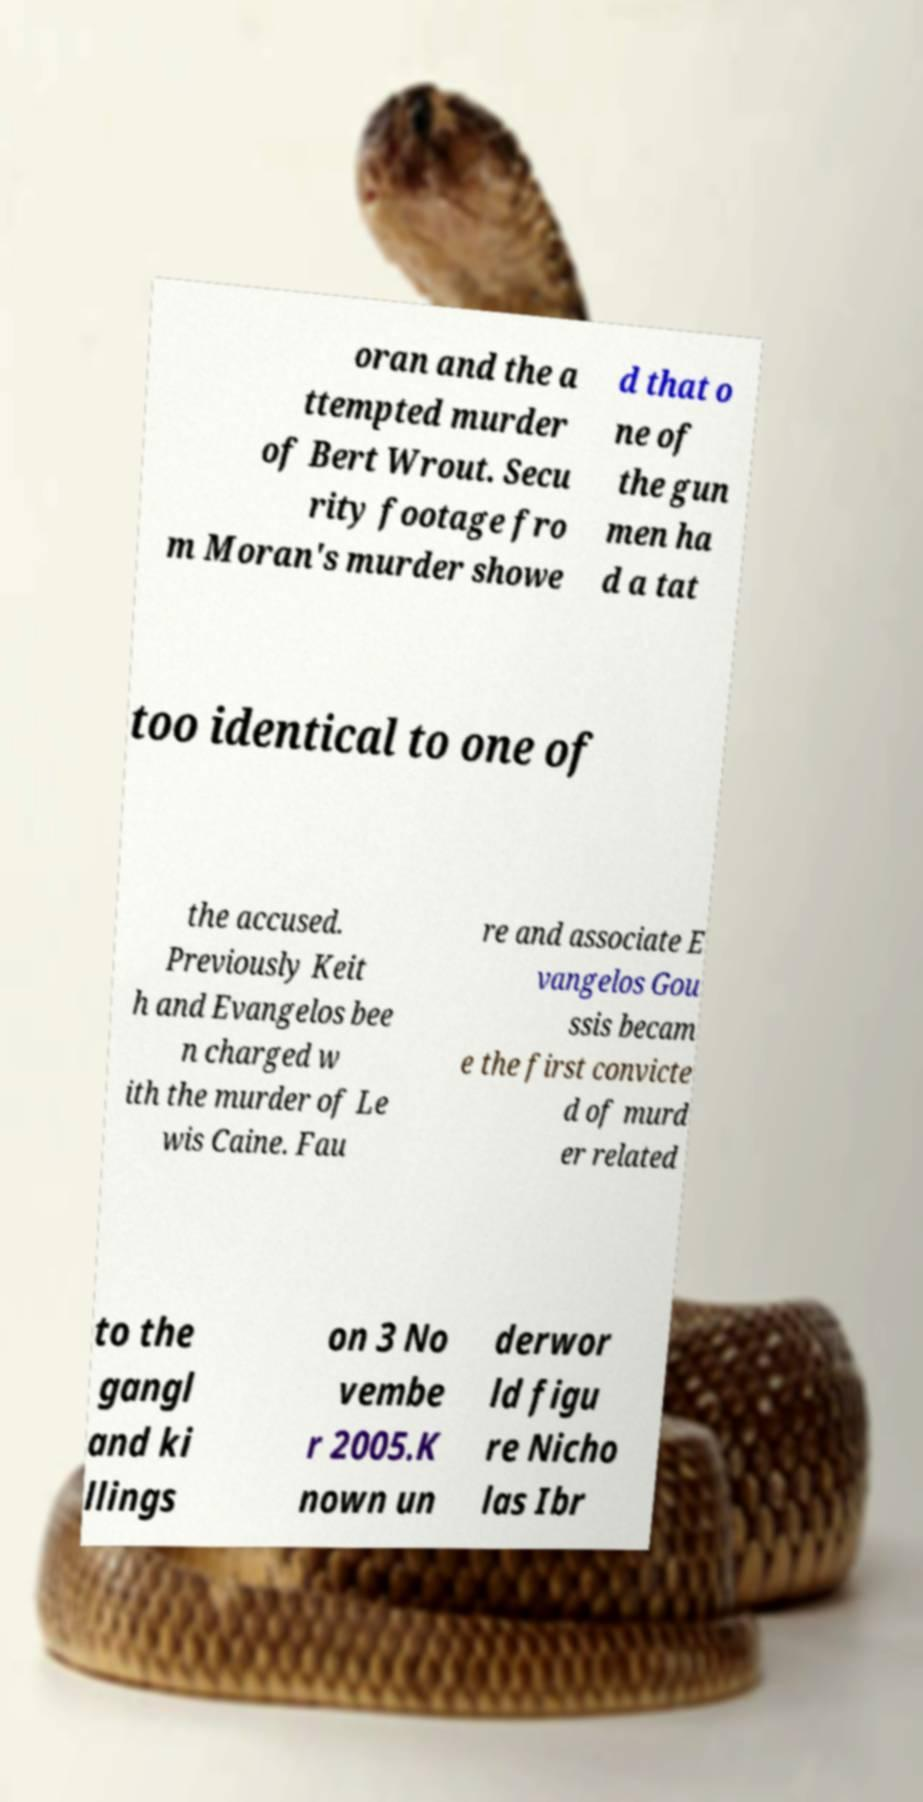Could you extract and type out the text from this image? oran and the a ttempted murder of Bert Wrout. Secu rity footage fro m Moran's murder showe d that o ne of the gun men ha d a tat too identical to one of the accused. Previously Keit h and Evangelos bee n charged w ith the murder of Le wis Caine. Fau re and associate E vangelos Gou ssis becam e the first convicte d of murd er related to the gangl and ki llings on 3 No vembe r 2005.K nown un derwor ld figu re Nicho las Ibr 